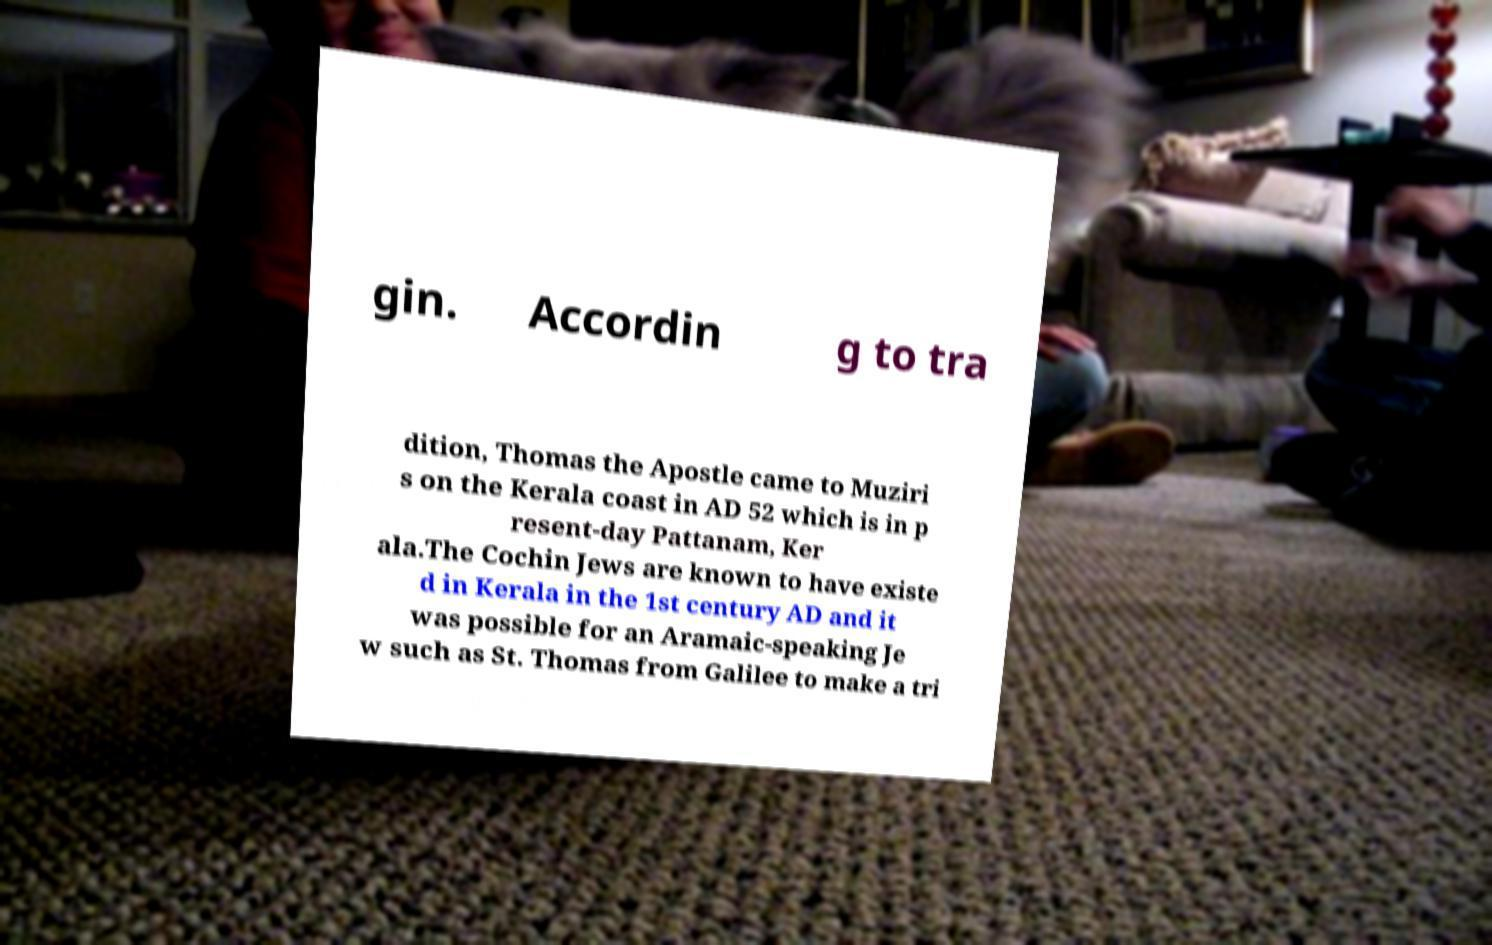There's text embedded in this image that I need extracted. Can you transcribe it verbatim? gin. Accordin g to tra dition, Thomas the Apostle came to Muziri s on the Kerala coast in AD 52 which is in p resent-day Pattanam, Ker ala.The Cochin Jews are known to have existe d in Kerala in the 1st century AD and it was possible for an Aramaic-speaking Je w such as St. Thomas from Galilee to make a tri 